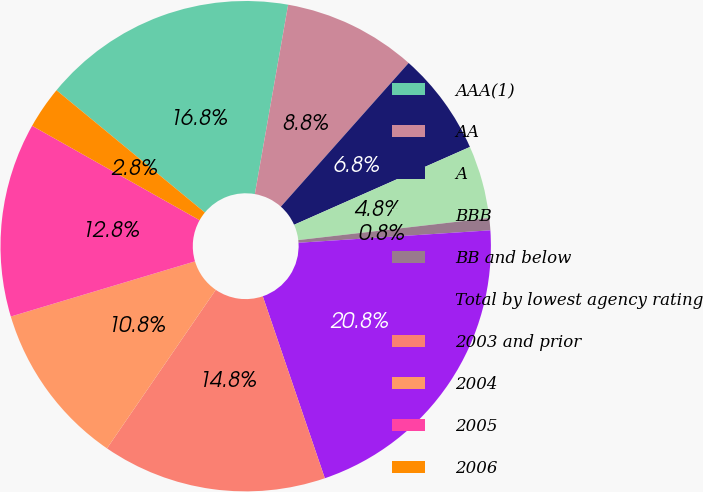<chart> <loc_0><loc_0><loc_500><loc_500><pie_chart><fcel>AAA(1)<fcel>AA<fcel>A<fcel>BBB<fcel>BB and below<fcel>Total by lowest agency rating<fcel>2003 and prior<fcel>2004<fcel>2005<fcel>2006<nl><fcel>16.8%<fcel>8.8%<fcel>6.8%<fcel>4.8%<fcel>0.8%<fcel>20.8%<fcel>14.8%<fcel>10.8%<fcel>12.8%<fcel>2.8%<nl></chart> 